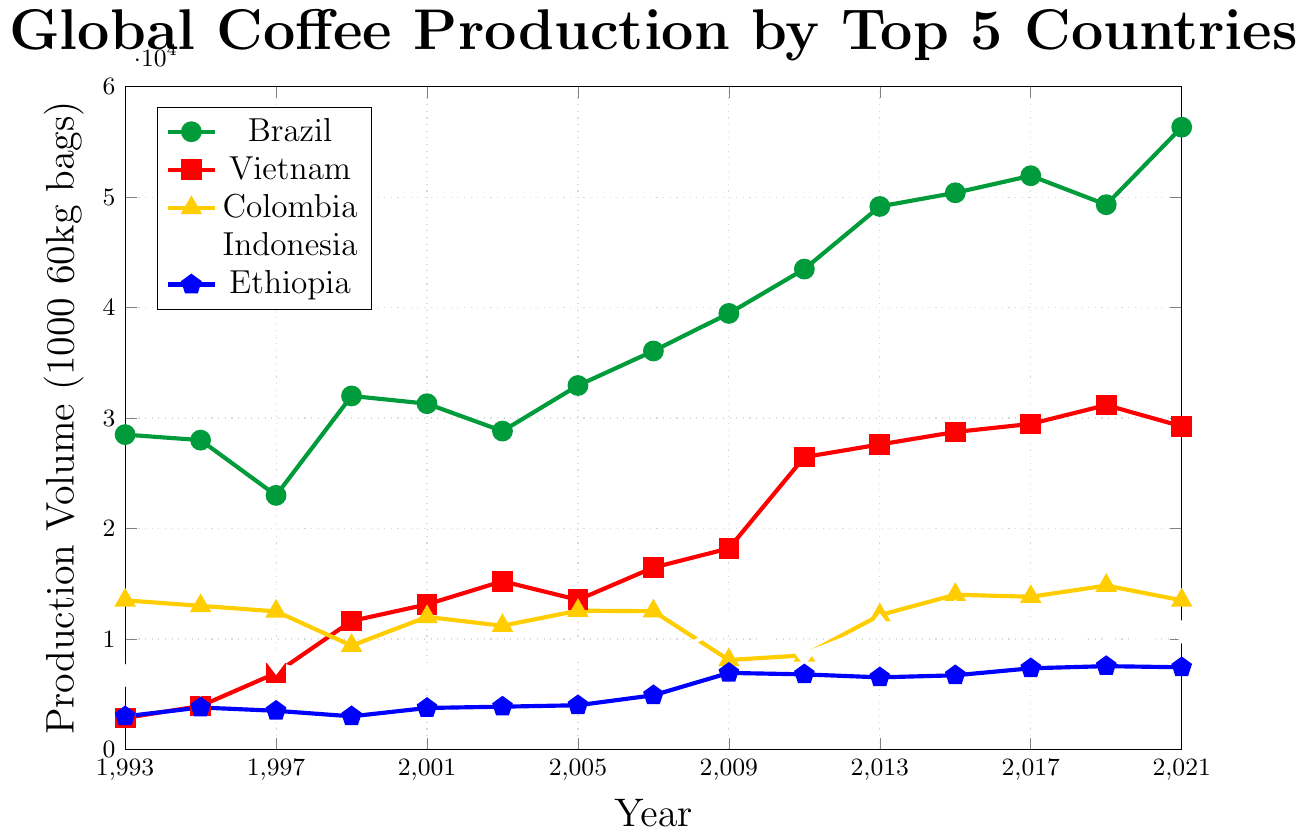What's the trend in Brazil's coffee production from 1993 to 2021? Brazil's coffee production shows an overall upward trend. Starting from 28500 (1000 60kg bags) in 1993, it fluctuates but generally increases, reaching 56327 (1000 60kg bags) in 2021.
Answer: Upward trend Which country had the highest production volume in 2013? By examining the 2013 data points for all countries, Brazil's production volume is the highest at 49152 (1000 60kg bags).
Answer: Brazil How does the coffee production in Vietnam in 1999 compare to that in 2021? Vietnam's coffee production increased significantly from 11630 (1000 60kg bags) in 1999 to 29250 (1000 60kg bags) in 2021.
Answer: Increased In which year did Ethiopia see a significant jump in production that surpassed the 4000 (1000 60kg bags) mark for the first time? Observing Ethiopia's data, the production volume surpassed 4000 (1000 60kg bags) in 2007, reaching 4906 (1000 60kg bags).
Answer: 2007 Which country had the lowest production in 1997? By comparing the 1997 data points for all countries, Mexico had the lowest production at 1900 (1000 60kg bags).
Answer: Mexico Calculate the average coffee production of Colombia from 1993 to 2021. Calculating the average: (13500 + 13000 + 12500 + 9400 + 11999 + 11197 + 12564 + 12515 + 8098 + 8523 + 12163 + 14009 + 13824 + 14835 + 13500) / 15 = 12449.133
Answer: 12449.133 For how many years did Brazil's production volume stay below 35000 (1000 60kg bags)? Examining the years and Brazil's production: 1993, 1995, 1997, 2001, 2003. The production was below 35000 for 5 years.
Answer: 5 Between which consecutive years did Vietnam see the highest increase in production volume? Observing Vietnam's data, the highest increase occurred between 2009 (18200) and 2011 (26467), an increase of 8267 (1000 60kg bags).
Answer: 2009 and 2011 What was the production volume of Indonesia and Ethiopia combined in 2009? Adding Indonesia's and Ethiopia's production volumes in 2009: 11380 (Indonesia) + 6931 (Ethiopia) = 18311 (1000 60kg bags).
Answer: 18311 Identify the country with the steadiest growth in production volumes over the period. By comparing trends, Vietnam shows a relatively steady growth with fewer large fluctuations in production volumes rising consistently from 2850 (1993) to 29250 (2021).
Answer: Vietnam 